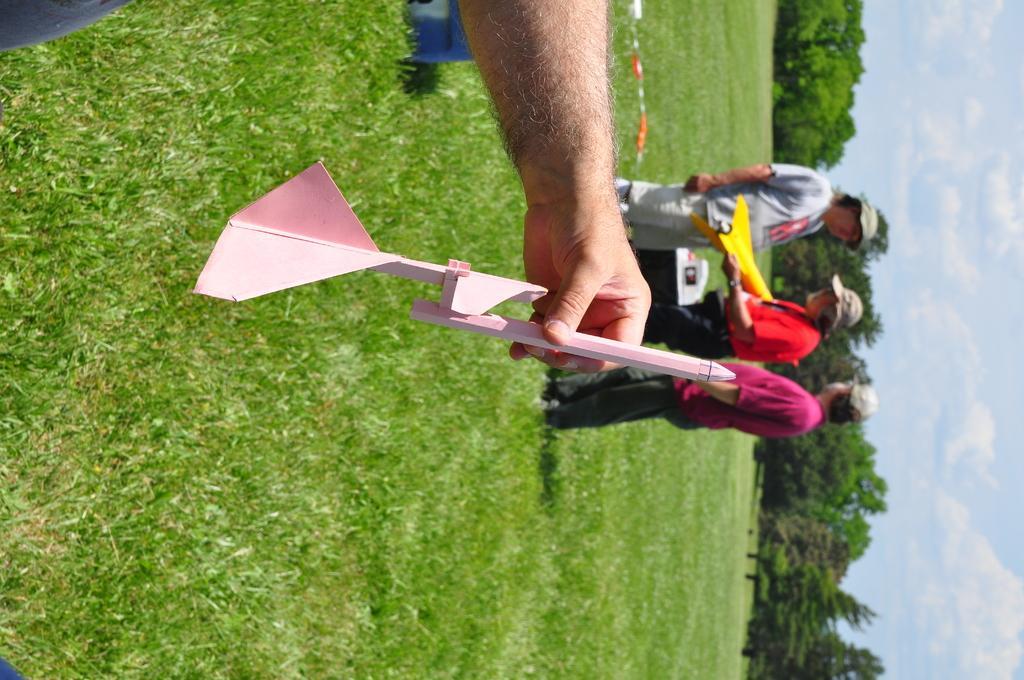Can you describe this image briefly? In this image we can see the hand of a person, through his face is not visible. Here we can see the hand holding a flying object. Here we can see three persons. Here we can see the caps on their head. Here we can see the grass. Here we can see the trees on the right side. This is a sky with clouds. 